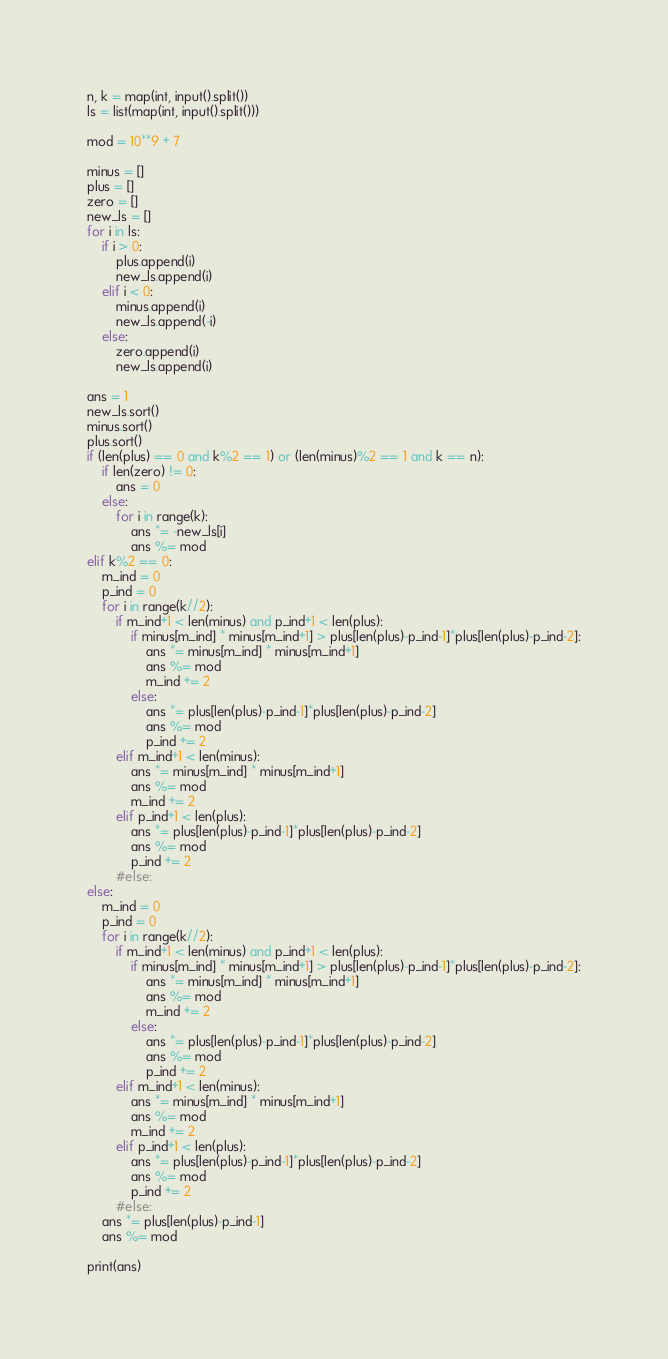<code> <loc_0><loc_0><loc_500><loc_500><_Python_>n, k = map(int, input().split())
ls = list(map(int, input().split()))

mod = 10**9 + 7

minus = []
plus = []
zero = []
new_ls = []
for i in ls:
    if i > 0:
        plus.append(i)
        new_ls.append(i)
    elif i < 0:
        minus.append(i)
        new_ls.append(-i)
    else:
        zero.append(i)
        new_ls.append(i)

ans = 1
new_ls.sort()
minus.sort()
plus.sort()
if (len(plus) == 0 and k%2 == 1) or (len(minus)%2 == 1 and k == n):
    if len(zero) != 0:
        ans = 0
    else:
        for i in range(k):
            ans *= -new_ls[i]
            ans %= mod
elif k%2 == 0:
    m_ind = 0
    p_ind = 0
    for i in range(k//2):
        if m_ind+1 < len(minus) and p_ind+1 < len(plus):
            if minus[m_ind] * minus[m_ind+1] > plus[len(plus)-p_ind-1]*plus[len(plus)-p_ind-2]:
                ans *= minus[m_ind] * minus[m_ind+1]
                ans %= mod
                m_ind += 2
            else:
                ans *= plus[len(plus)-p_ind-1]*plus[len(plus)-p_ind-2]
                ans %= mod
                p_ind += 2
        elif m_ind+1 < len(minus):
            ans *= minus[m_ind] * minus[m_ind+1]
            ans %= mod
            m_ind += 2
        elif p_ind+1 < len(plus):
            ans *= plus[len(plus)-p_ind-1]*plus[len(plus)-p_ind-2]
            ans %= mod
            p_ind += 2
        #else:
else:
    m_ind = 0
    p_ind = 0
    for i in range(k//2):
        if m_ind+1 < len(minus) and p_ind+1 < len(plus):
            if minus[m_ind] * minus[m_ind+1] > plus[len(plus)-p_ind-1]*plus[len(plus)-p_ind-2]:
                ans *= minus[m_ind] * minus[m_ind+1]
                ans %= mod
                m_ind += 2
            else:
                ans *= plus[len(plus)-p_ind-1]*plus[len(plus)-p_ind-2]
                ans %= mod
                p_ind += 2
        elif m_ind+1 < len(minus):
            ans *= minus[m_ind] * minus[m_ind+1]
            ans %= mod
            m_ind += 2
        elif p_ind+1 < len(plus):
            ans *= plus[len(plus)-p_ind-1]*plus[len(plus)-p_ind-2]
            ans %= mod
            p_ind += 2
        #else:
    ans *= plus[len(plus)-p_ind-1]
    ans %= mod

print(ans)</code> 